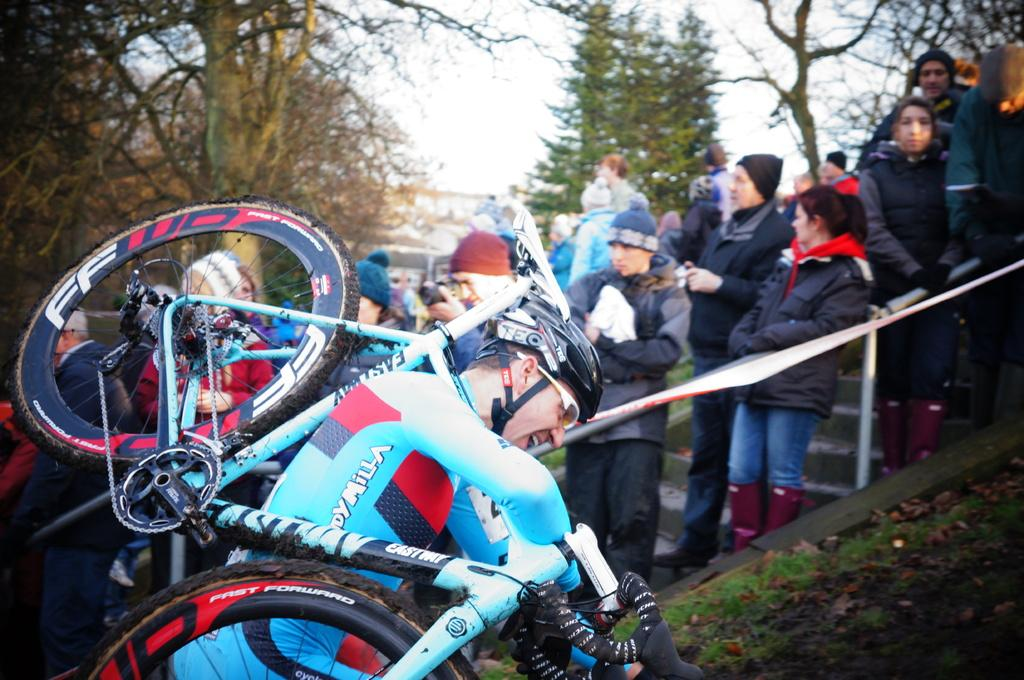What is the man in the image doing? The man in the image is carrying a bicycle. What can be seen in the background of the image? There are multiple people standing in the background of the image. What are the people in the background doing? The people in the background are watching a show. How many sheets of paper are visible in the image? There is no paper present in the image. What is the amount of money the man is carrying with the bicycle? The image does not provide information about the man carrying money; it only shows him carrying a bicycle. 